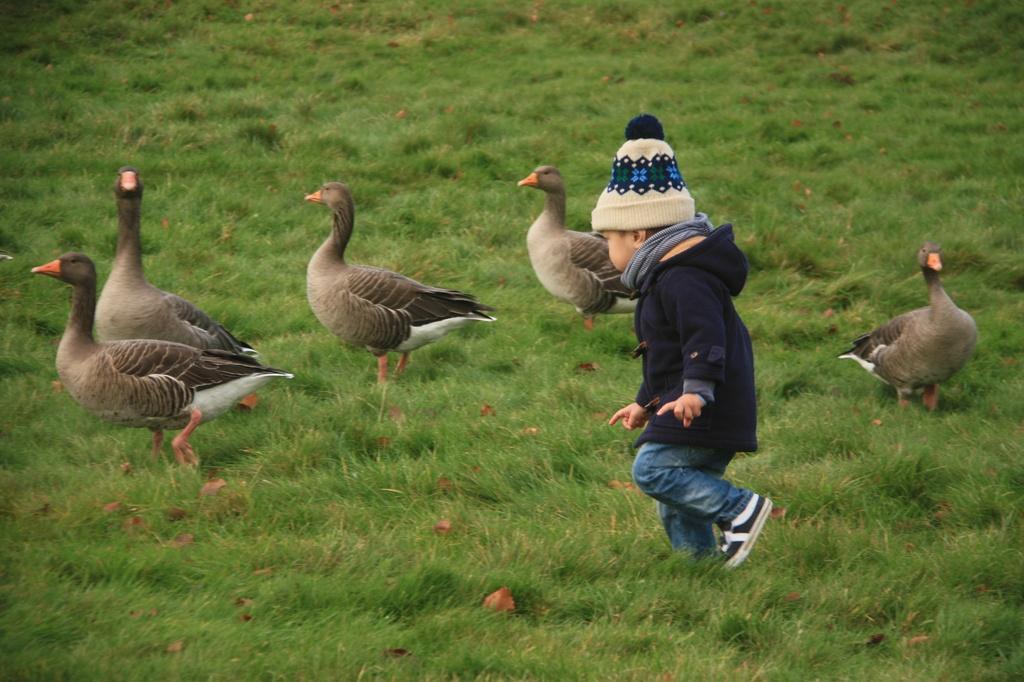How would you summarize this image in a sentence or two? In this picture we can observe some ducks which are in brown and white color. These ducks are on the ground. We can observe a kid walking on the ground. He is wearing blue color hoodie and a cap on his head. There is some grass on the ground. 